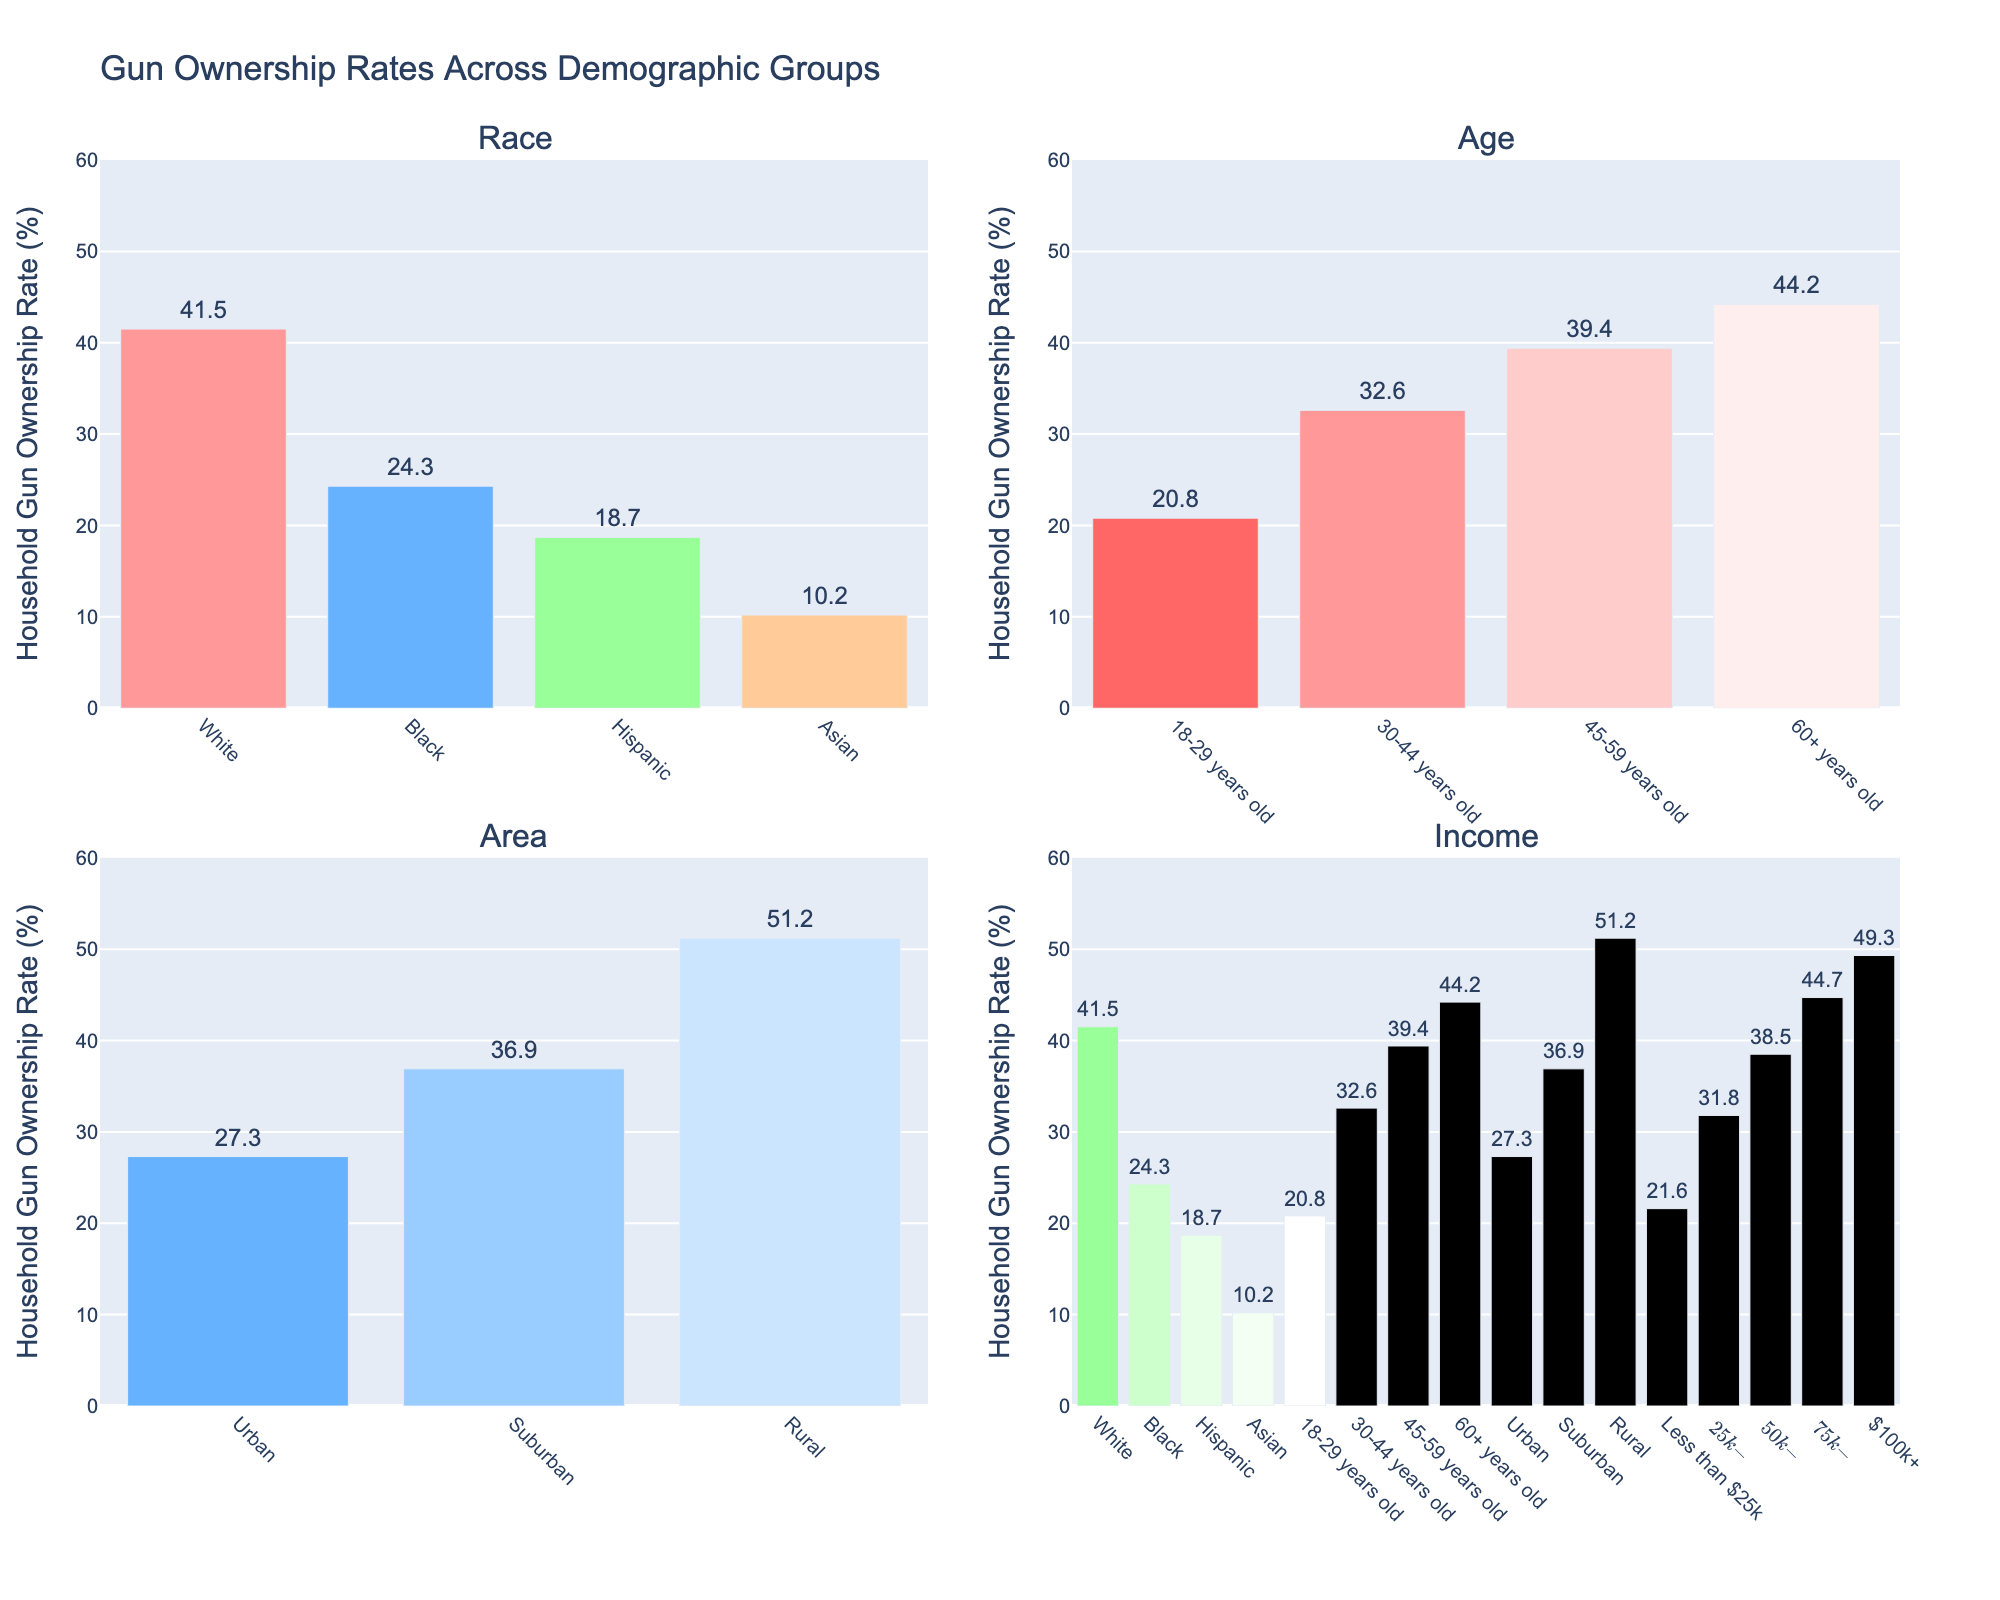What's the title of the figure? Look at the centered text at the top of the figure.
Answer: Gun Ownership Rates Across Demographic Groups How many subplots are present in the figure? Identify the total number of individual plots grouped together within the main figure.
Answer: 4 Which racial group has the highest household gun ownership rate? Examine the first subplot labeled "Race". Look for the bar with the highest value among the racial groups listed.
Answer: White What is the difference in household gun ownership rate between those aged 60+ and those aged 18-29 years old? In the "Age" subplot, find the values for both the 60+ group and the 18-29 years old group, and subtract the latter from the former (44.2 - 20.8).
Answer: 23.4 Which demographic area has the lowest gun ownership rate? Look at the "Area" subplot and find the bar with the smallest value.
Answer: Urban How does the gun ownership rate in Suburban areas compare to Urban areas? Compare the heights of the bars labeled Suburban and Urban in the "Area" subplot.
Answer: Higher Which income group has the highest gun ownership rate? Refer to the "Income" subplot and find the bar with the highest value.
Answer: $100k+ What is the average household gun ownership rate for all age groups? Add the gun ownership rates for all age groups shown in the "Age" subplot, then divide by the number of age groups (20.8 + 32.6 + 39.4 + 44.2) / 4.
Answer: 34.25 Compare the household gun ownership rates between Black and Hispanic demographics. Which is higher? In the "Race" subplot, find the bars corresponding to Black and Hispanic, and compare their heights.
Answer: Black What trend can be observed in gun ownership rates with respect to household income? In the "Income" subplot, observe how the height of bars change as you go from lower to higher income groups.
Answer: Increases with income 